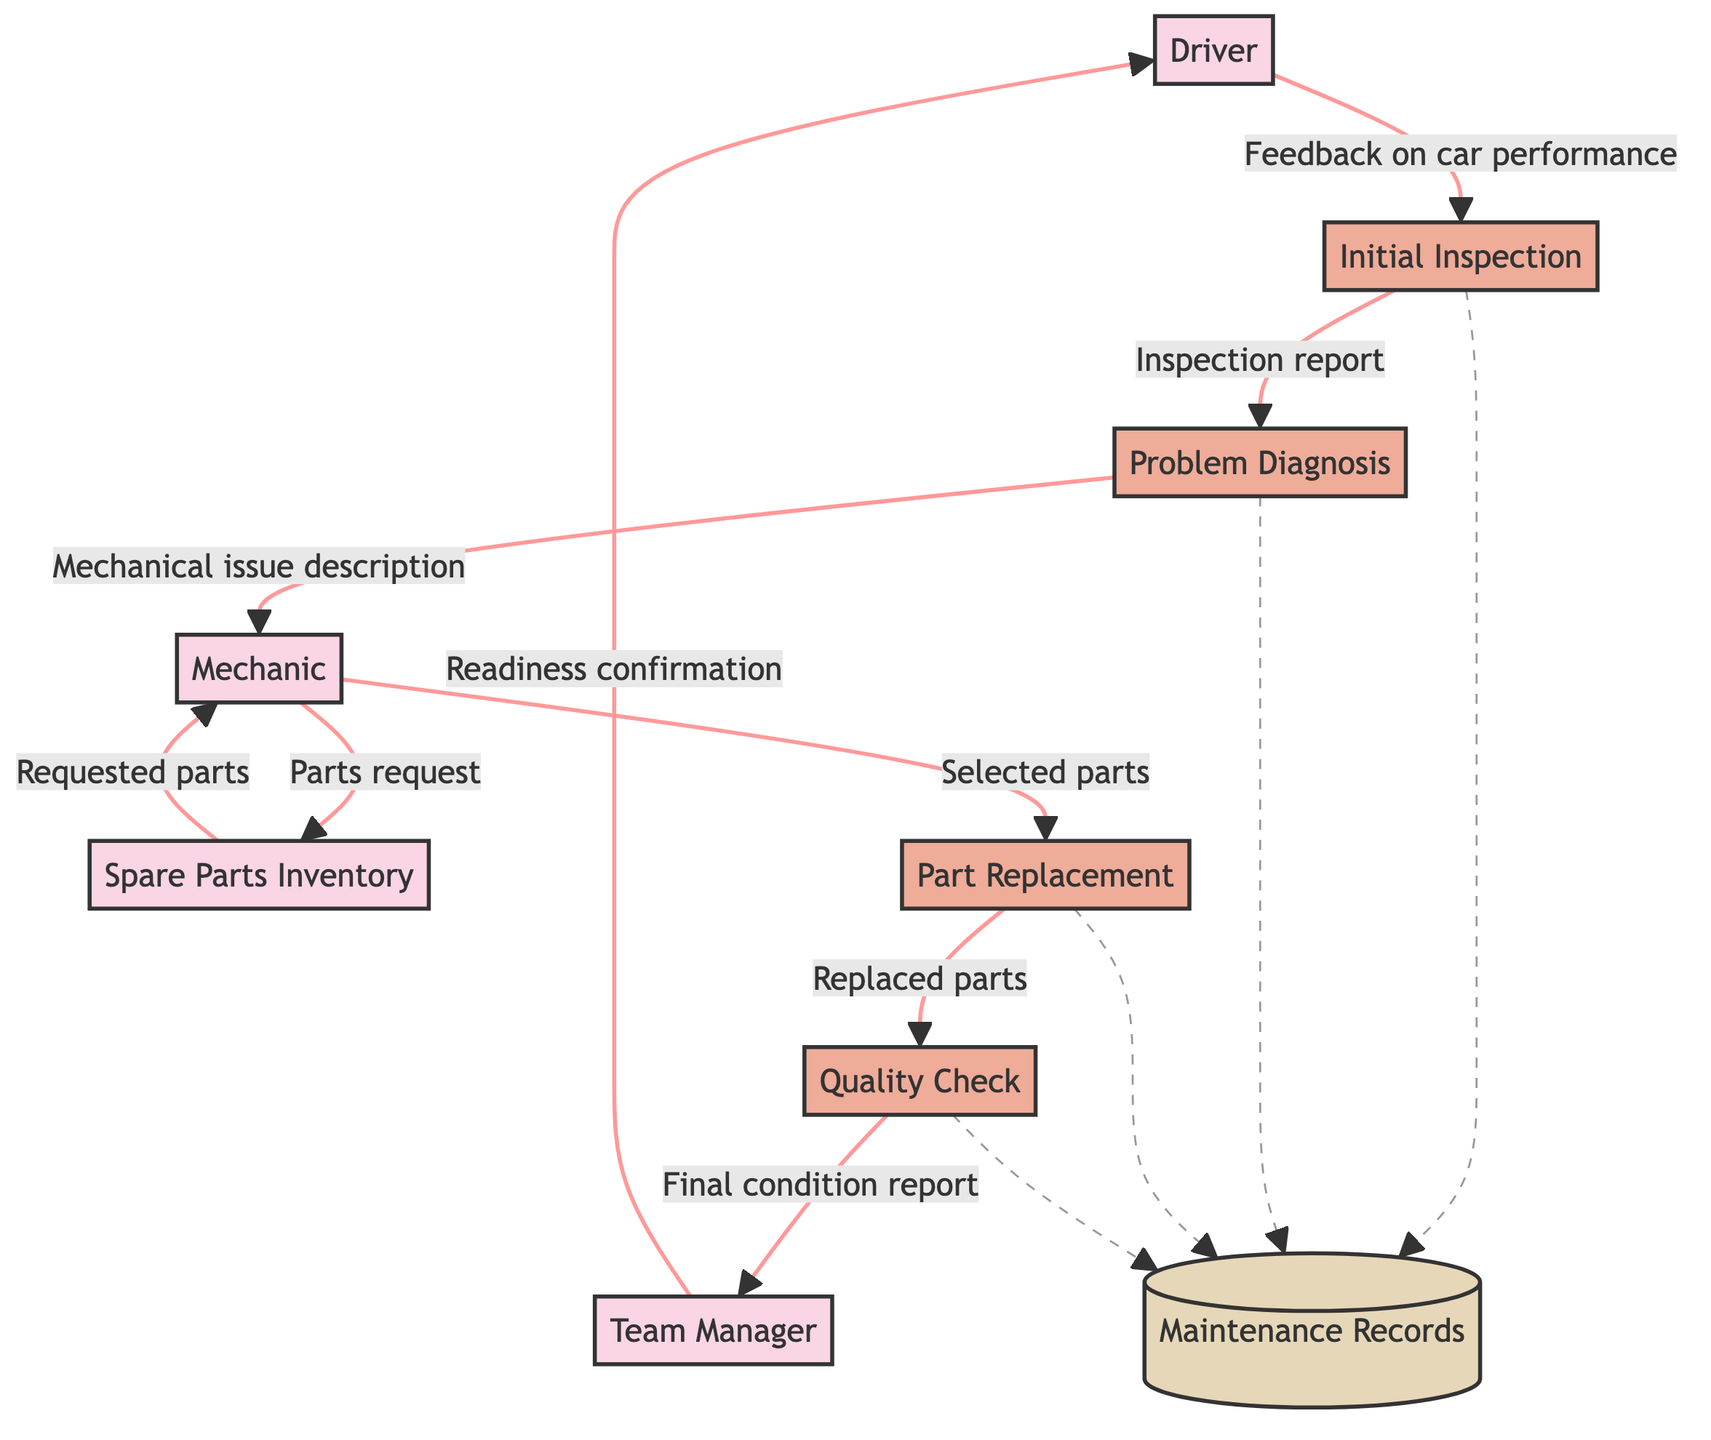What is the first process in the maintenance workflow? The first process is indicated by the arrow leading from the Driver to Initial Inspection. This shows that the Initial Inspection is the starting point in the workflow based on the feedback provided by the Driver.
Answer: Initial Inspection How many entities are involved in the Race Car Maintenance Workflow? To find the number of entities, we can count all the boxes labeled as entities in the diagram. There are six entities listed: Race Car, Driver, Mechanic, Team Manager, Garage, and Spare Parts Inventory.
Answer: Six What feedback does the Driver provide to start the process? The contribution by the Driver to the Initial Inspection is depicted with an arrow indicating "Feedback on car performance." This feedback is crucial for identifying issues that might need repair.
Answer: Feedback on car performance What is the output of the Problem Diagnosis process? The Problem Diagnosis process sends an output to the Mechanic, denoted by an arrow that states "Mechanical issue description." This output contains the details of the problems identified during the diagnosis.
Answer: Mechanical issue description How does the Mechanic request parts needed for repairs? The Mechanic sends a request to the Spare Parts Inventory, which is illustrated by an arrow along with the label "Parts request." This step demonstrates how the parts needed for maintenance are sourced.
Answer: Parts request What is the consequence of the Quality Check process? The final output from the Quality Check process is represented by an arrow moving towards the Team Manager labeled "Final condition report." This report indicates whether the car is ready or not after maintenance.
Answer: Final condition report Which process comes after the Part Replacement? Following the Part Replacement, the process leading next is Quality Check, marked by an arrow indicating the flow of information from the Part Replacement to Quality Check. This sequence emphasizes the necessary verification after parts are replaced.
Answer: Quality Check What type of data flows are represented by dotted lines in the diagram? The dotted lines show the maintenance records that are created during several processes in the workflow, including Initial Inspection, Problem Diagnosis, Part Replacement, and Quality Check. These record the details of the maintenance.
Answer: Maintenance Records What's the final confirmation the Team Manager gives to the Driver? The Team Manager communicates the confirmation of readiness to the Driver, represented by an arrow labeled "Readiness confirmation." This denotes that maintenance has been completed and the car is ready for racing.
Answer: Readiness confirmation 